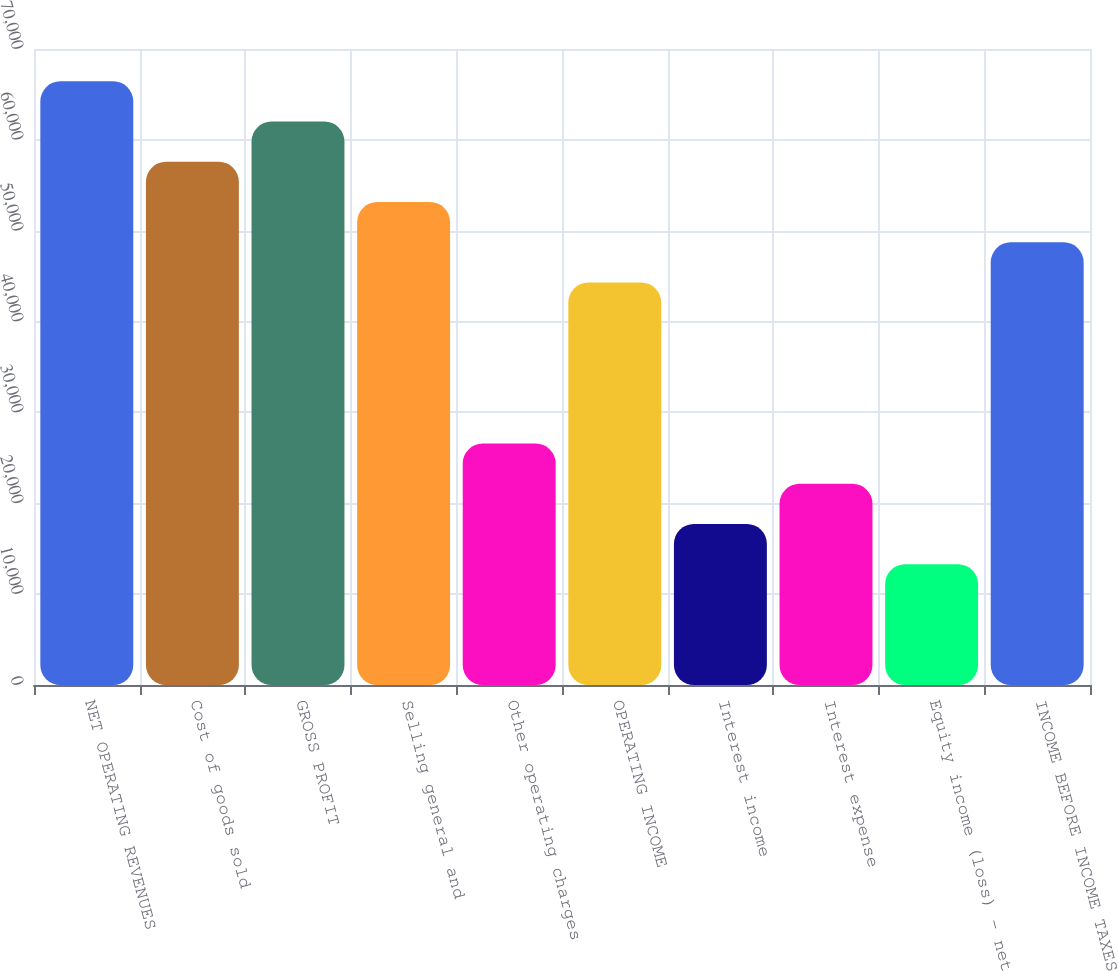Convert chart to OTSL. <chart><loc_0><loc_0><loc_500><loc_500><bar_chart><fcel>NET OPERATING REVENUES<fcel>Cost of goods sold<fcel>GROSS PROFIT<fcel>Selling general and<fcel>Other operating charges<fcel>OPERATING INCOME<fcel>Interest income<fcel>Interest expense<fcel>Equity income (loss) - net<fcel>INCOME BEFORE INCOME TAXES<nl><fcel>66440.1<fcel>57581.7<fcel>62010.9<fcel>53152.4<fcel>26577<fcel>44294<fcel>17718.6<fcel>22147.8<fcel>13289.4<fcel>48723.2<nl></chart> 